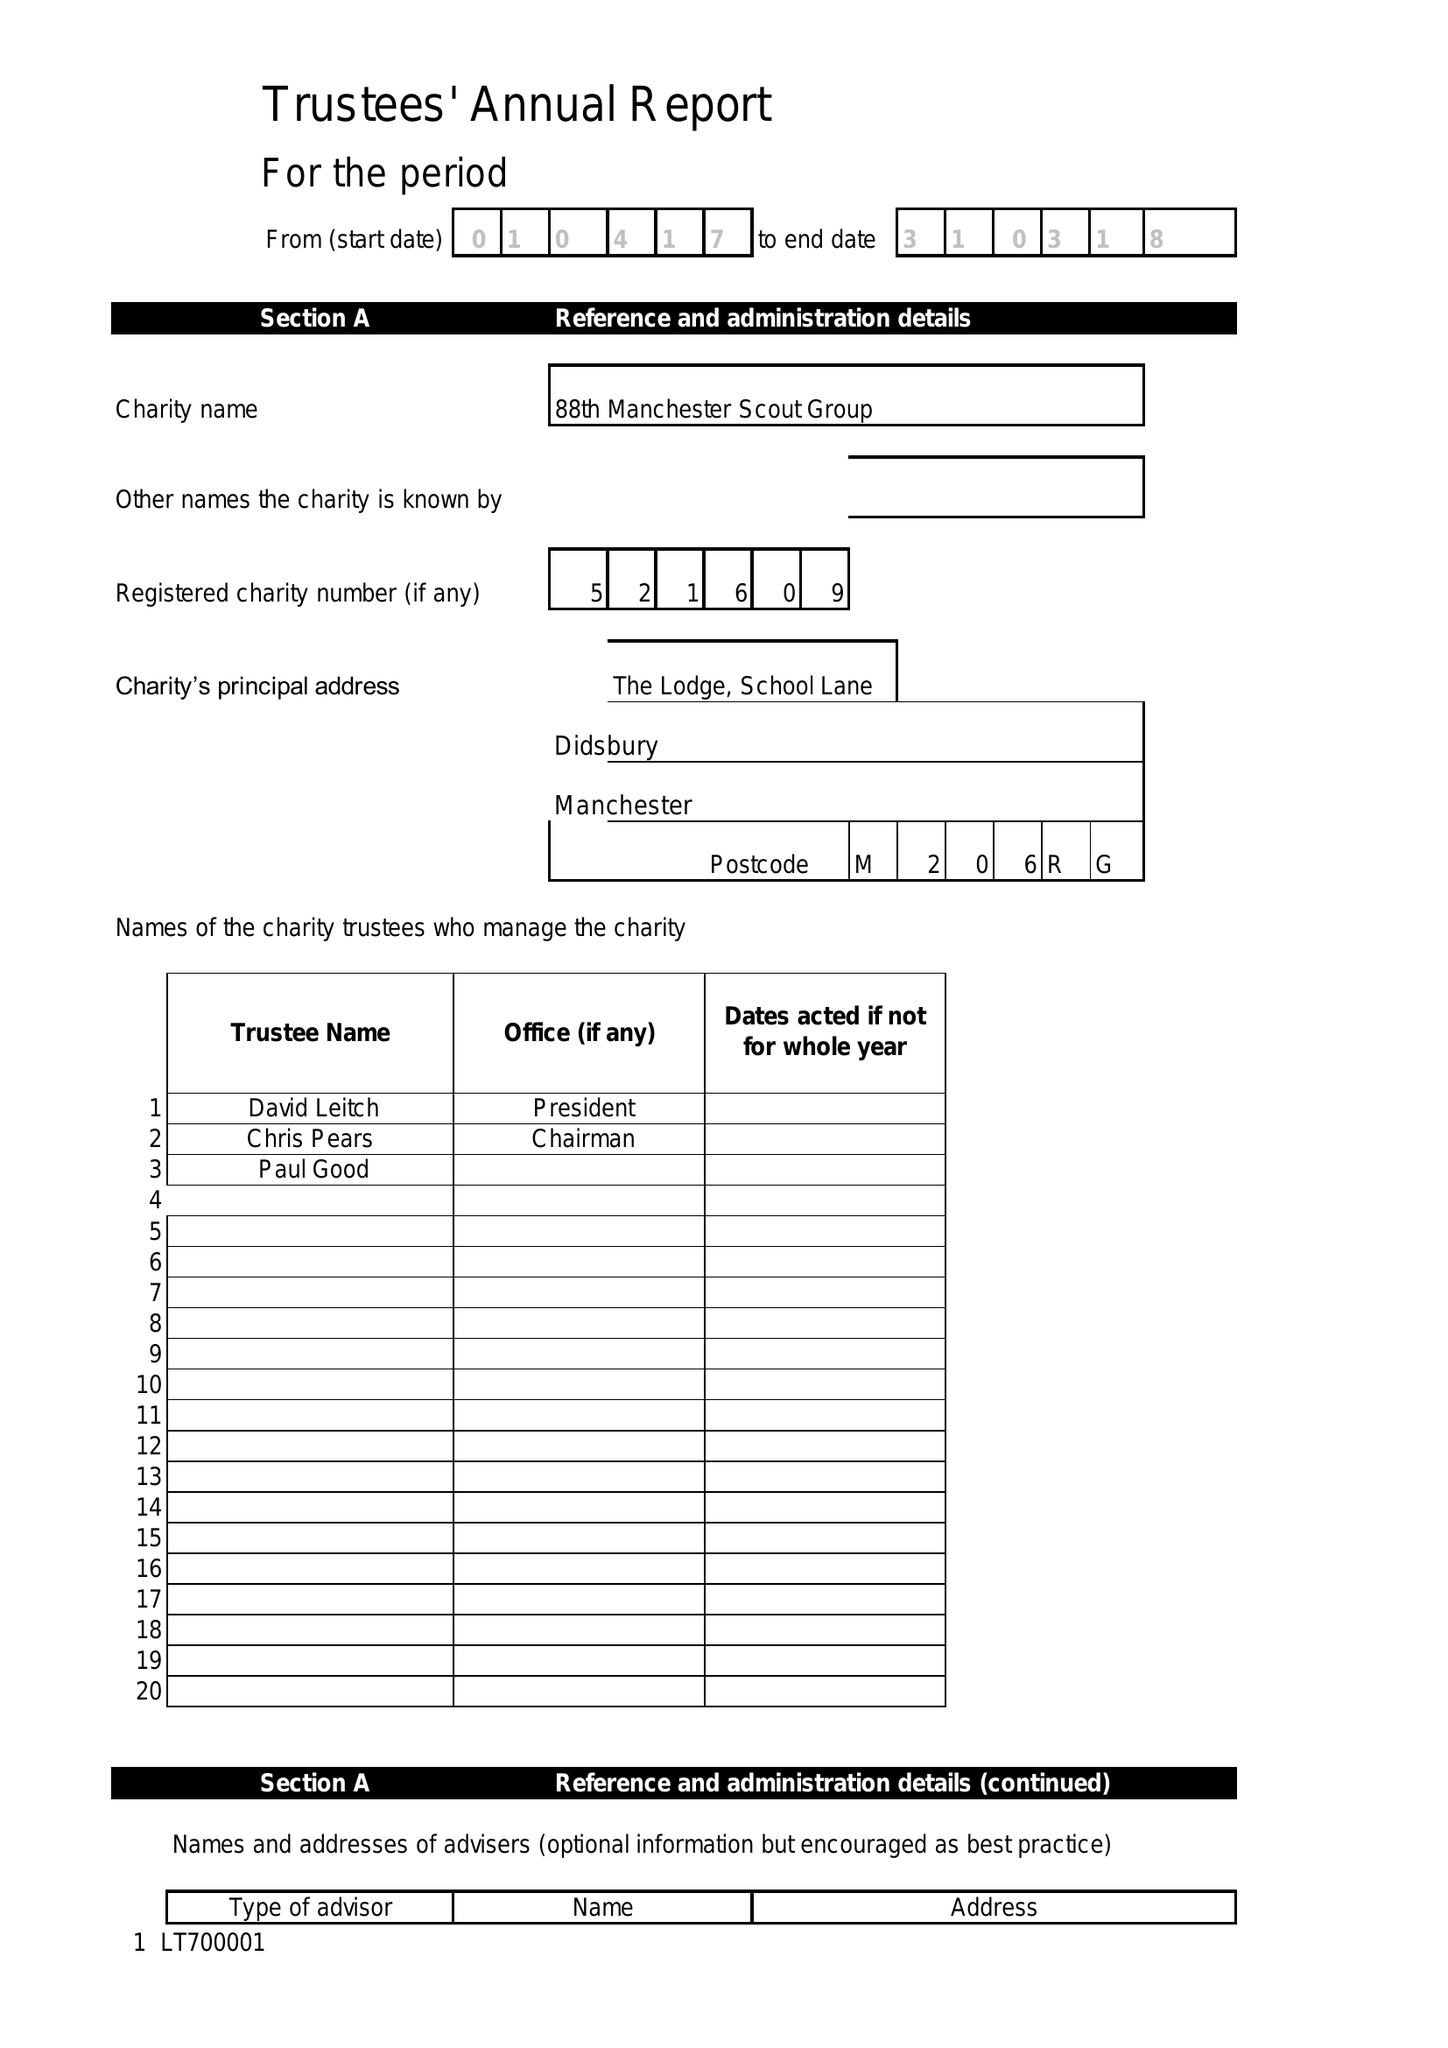What is the value for the address__post_town?
Answer the question using a single word or phrase. STOCKPORT 